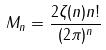Convert formula to latex. <formula><loc_0><loc_0><loc_500><loc_500>M _ { n } = \frac { 2 \zeta ( n ) n ! } { ( 2 \pi ) ^ { n } }</formula> 